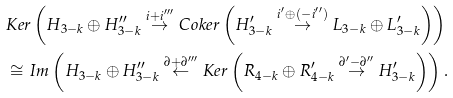Convert formula to latex. <formula><loc_0><loc_0><loc_500><loc_500>& K e r \left ( H _ { 3 - k } \oplus H _ { 3 - k } ^ { \prime \prime } \overset { i + i ^ { \prime \prime \prime } } { \rightarrow } C o k e r \left ( H _ { 3 - k } ^ { \prime } \overset { i ^ { \prime } \oplus \left ( - i ^ { \prime \prime } \right ) } { \rightarrow } L _ { 3 - k } \oplus L _ { 3 - k } ^ { \prime } \right ) \right ) \\ & \cong I m \left ( H _ { 3 - k } \oplus H _ { 3 - k } ^ { \prime \prime } \overset { \partial + \partial ^ { \prime \prime \prime } } { \leftarrow } K e r \left ( R _ { 4 - k } \oplus R _ { 4 - k } ^ { \prime } \overset { \partial ^ { \prime } - \partial ^ { \prime \prime } } { \rightarrow } H _ { 3 - k } ^ { \prime } \right ) \right ) .</formula> 